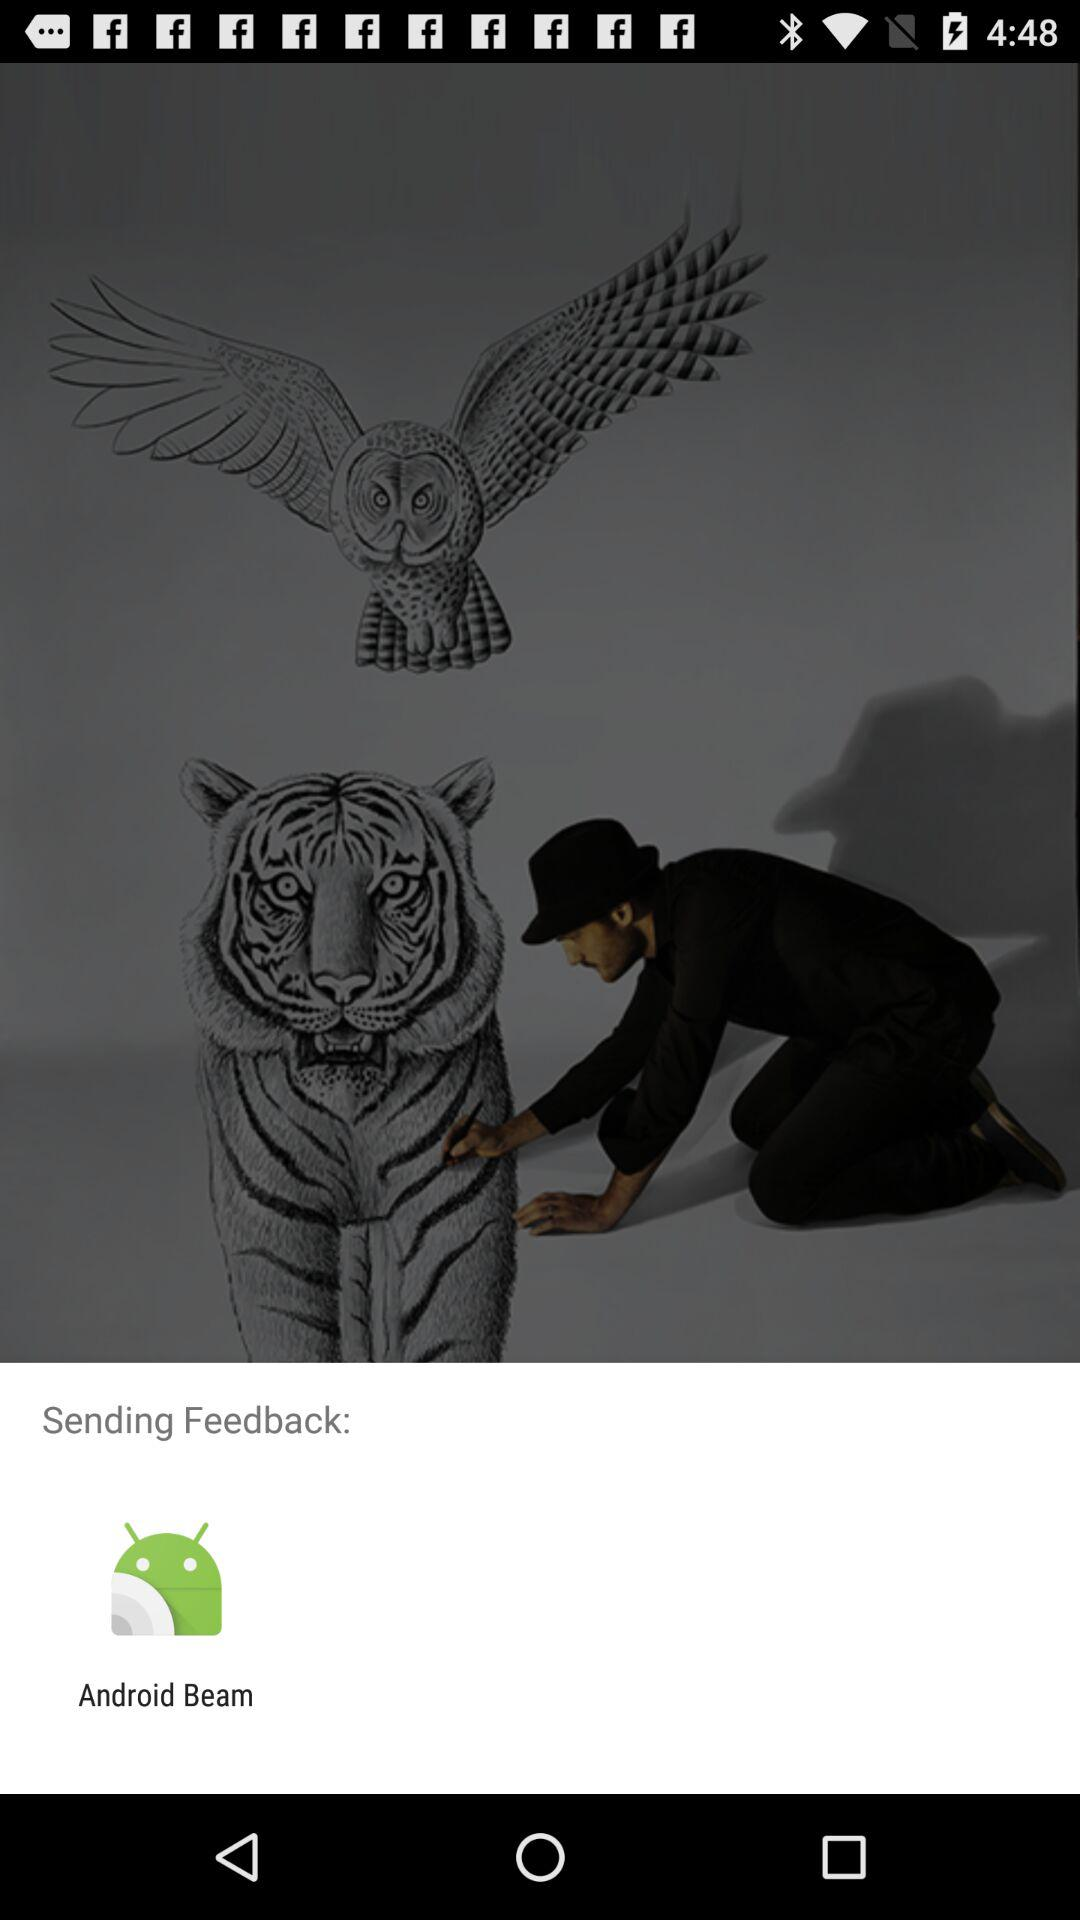By using what application can we send feedback? The application is "Android Beam". 